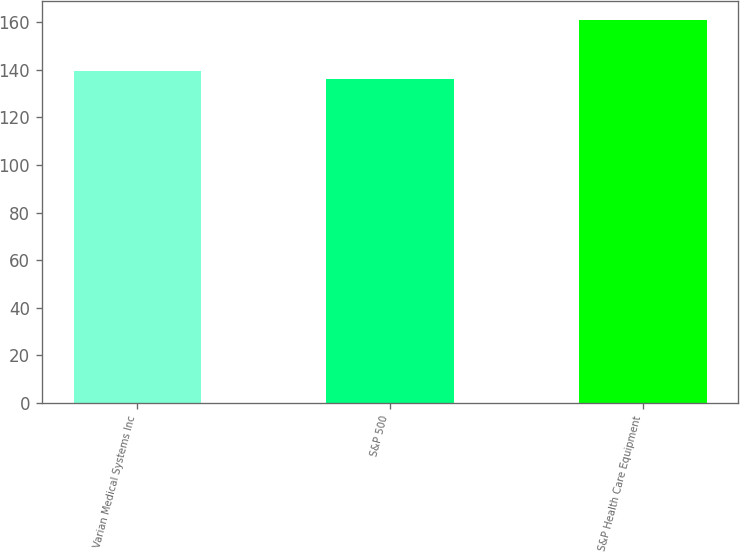Convert chart. <chart><loc_0><loc_0><loc_500><loc_500><bar_chart><fcel>Varian Medical Systems Inc<fcel>S&P 500<fcel>S&P Health Care Equipment<nl><fcel>139.67<fcel>136.07<fcel>160.76<nl></chart> 